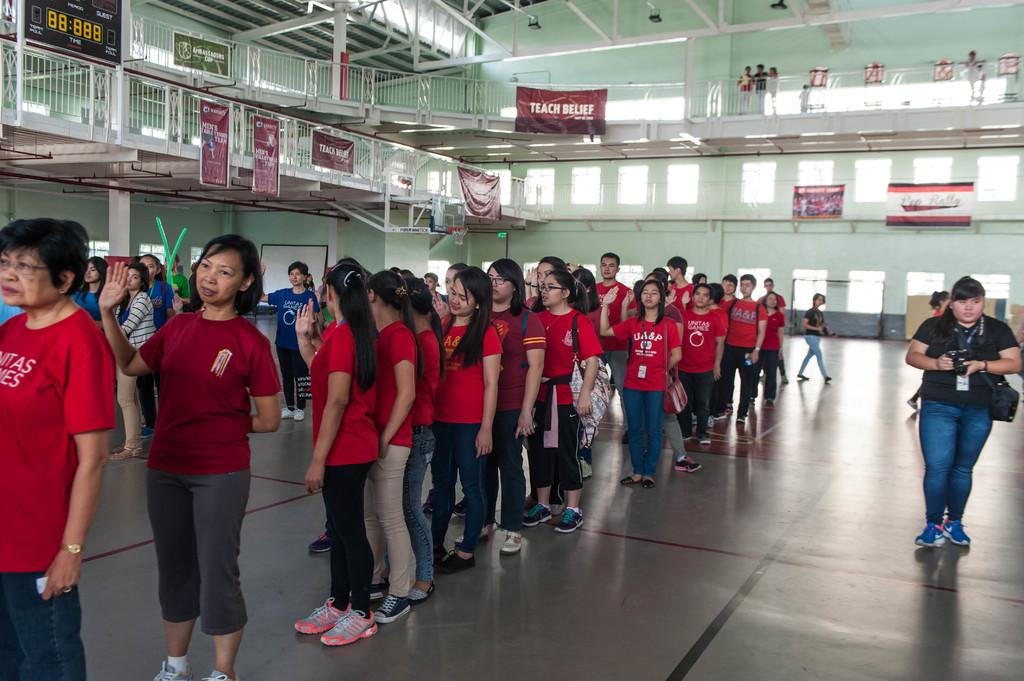What are the people in the image doing? There is a group of people on the floor in the image. What decorative elements can be seen in the image? There are banners in the image. What architectural features are present in the image? There are pillars in the image. What electronic device is visible in the image? There is a screen in the image. What is a flat, typically rectangular surface used for writing or displaying information in the image? There is a board in the image. What is a large, solid structure that separates or encloses space in the image? There is a wall in the image. What type of reward is the minister holding in the image? There is no minister or reward present in the image. What is the sun doing in the image? The sun is not present in the image; it is an outdoor celestial body. 